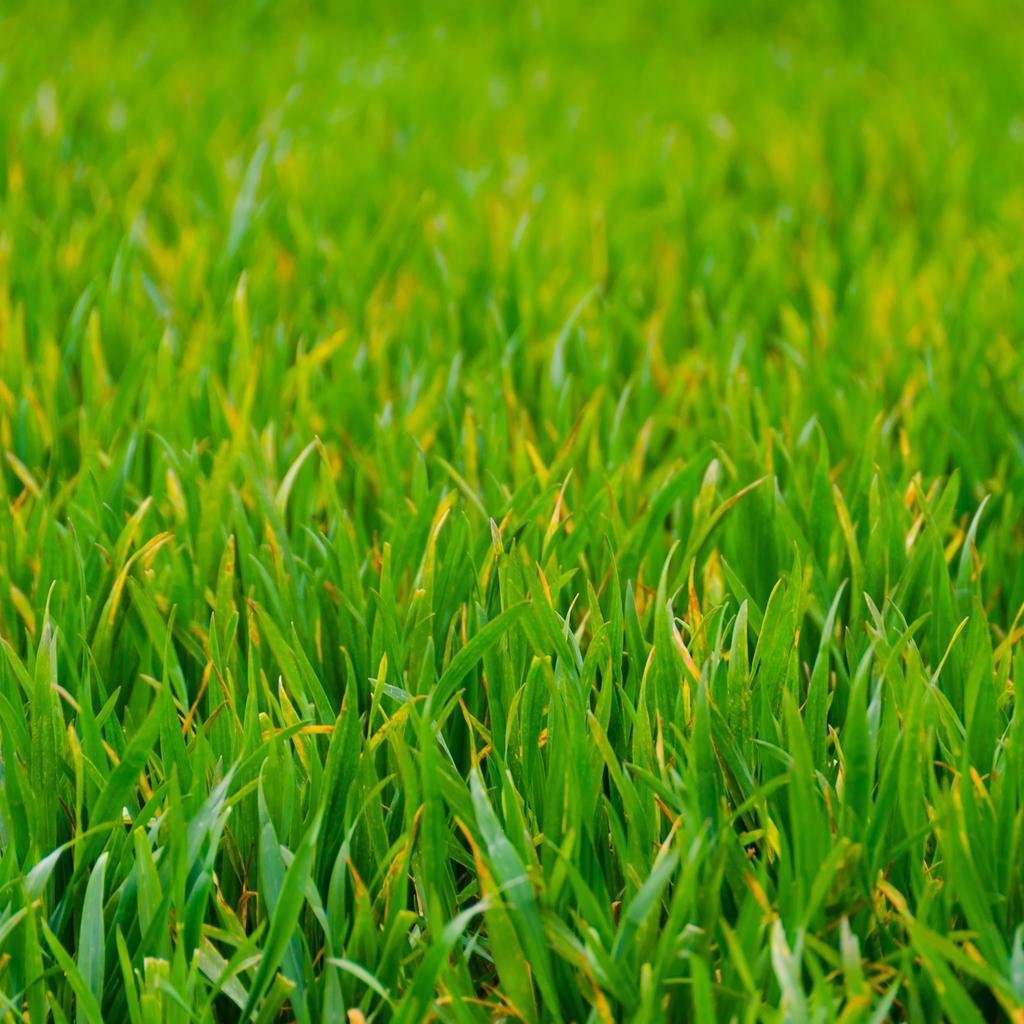Could you give a brief overview of what you see in this image? In the foreground of this image, there is grass. 